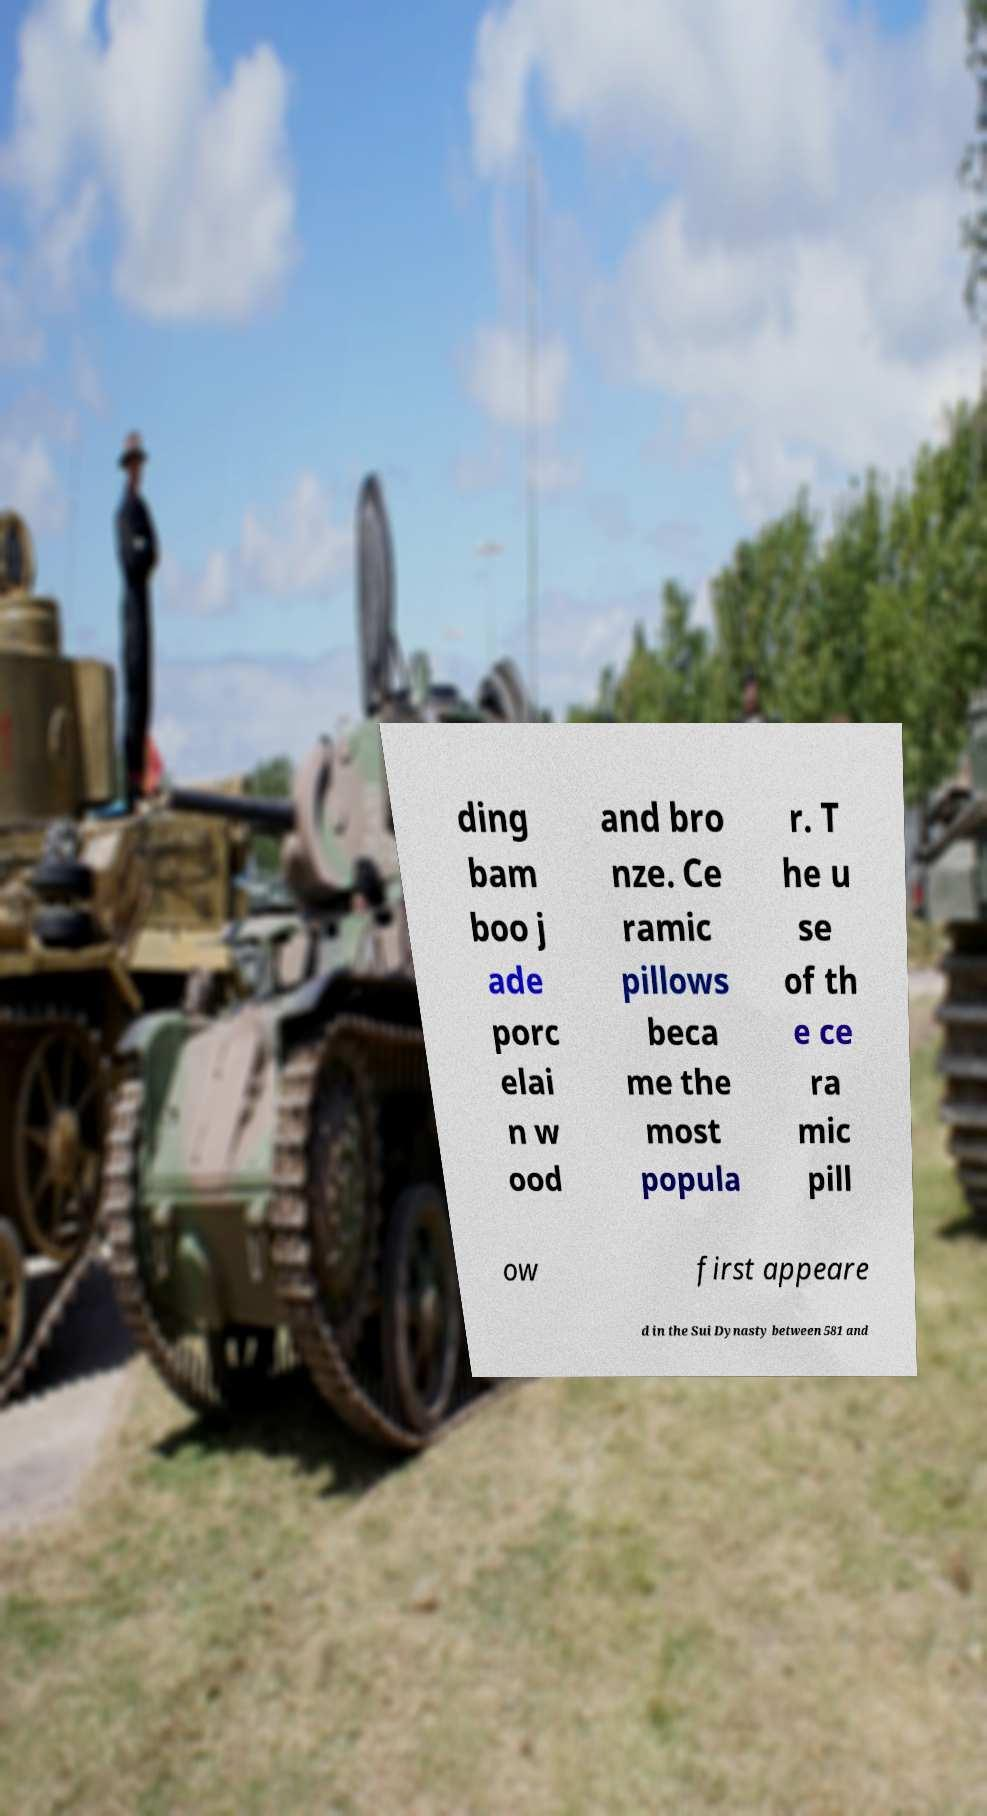Can you accurately transcribe the text from the provided image for me? ding bam boo j ade porc elai n w ood and bro nze. Ce ramic pillows beca me the most popula r. T he u se of th e ce ra mic pill ow first appeare d in the Sui Dynasty between 581 and 